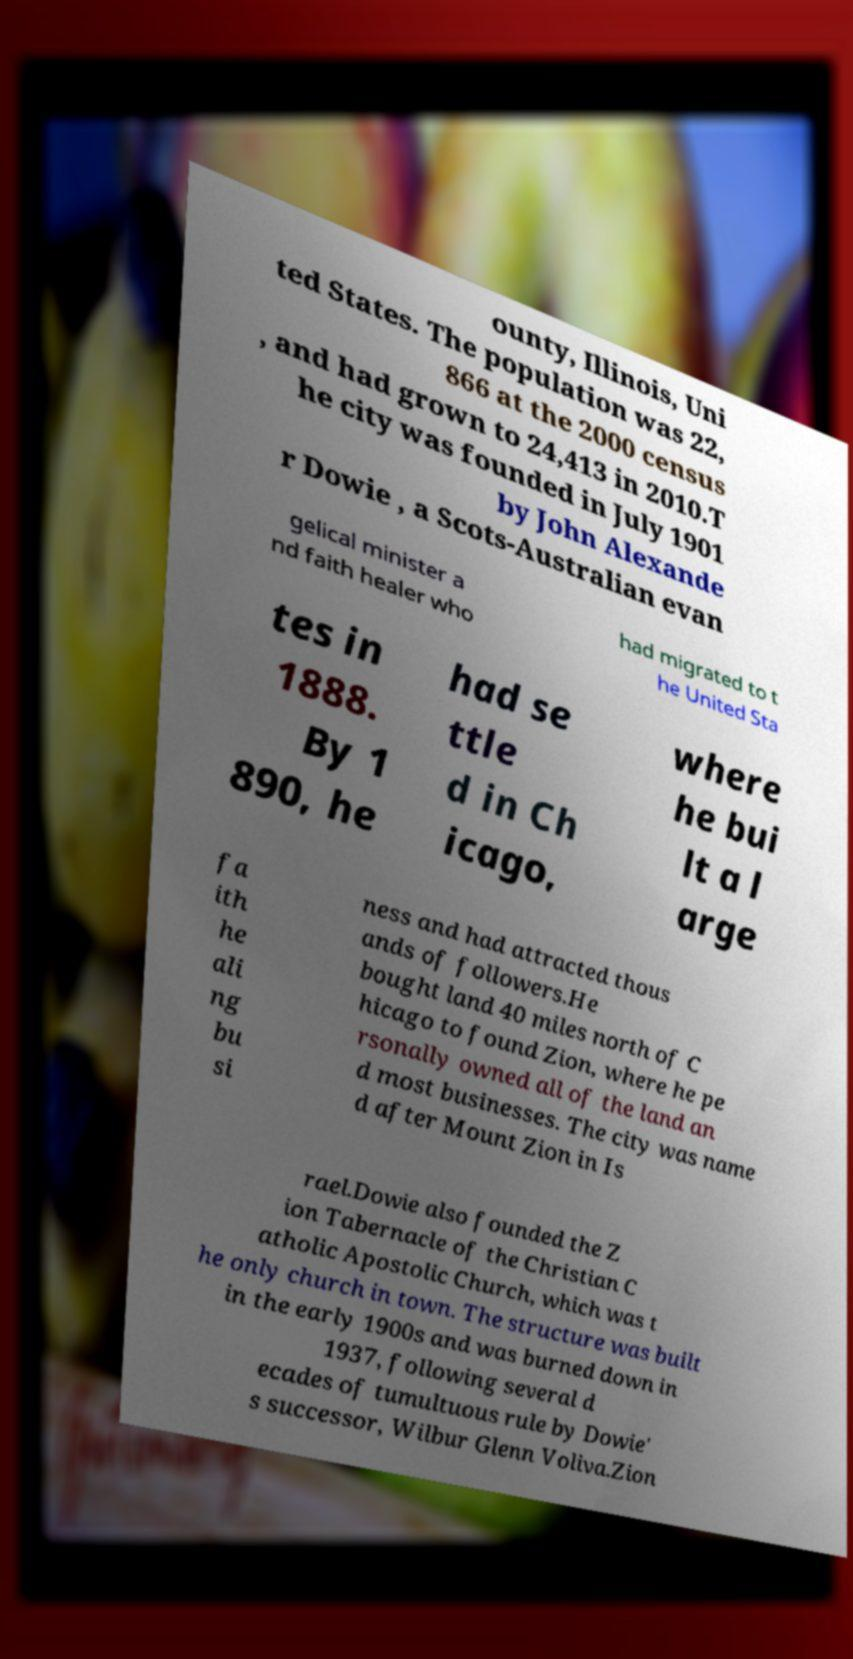I need the written content from this picture converted into text. Can you do that? ounty, Illinois, Uni ted States. The population was 22, 866 at the 2000 census , and had grown to 24,413 in 2010.T he city was founded in July 1901 by John Alexande r Dowie , a Scots-Australian evan gelical minister a nd faith healer who had migrated to t he United Sta tes in 1888. By 1 890, he had se ttle d in Ch icago, where he bui lt a l arge fa ith he ali ng bu si ness and had attracted thous ands of followers.He bought land 40 miles north of C hicago to found Zion, where he pe rsonally owned all of the land an d most businesses. The city was name d after Mount Zion in Is rael.Dowie also founded the Z ion Tabernacle of the Christian C atholic Apostolic Church, which was t he only church in town. The structure was built in the early 1900s and was burned down in 1937, following several d ecades of tumultuous rule by Dowie' s successor, Wilbur Glenn Voliva.Zion 